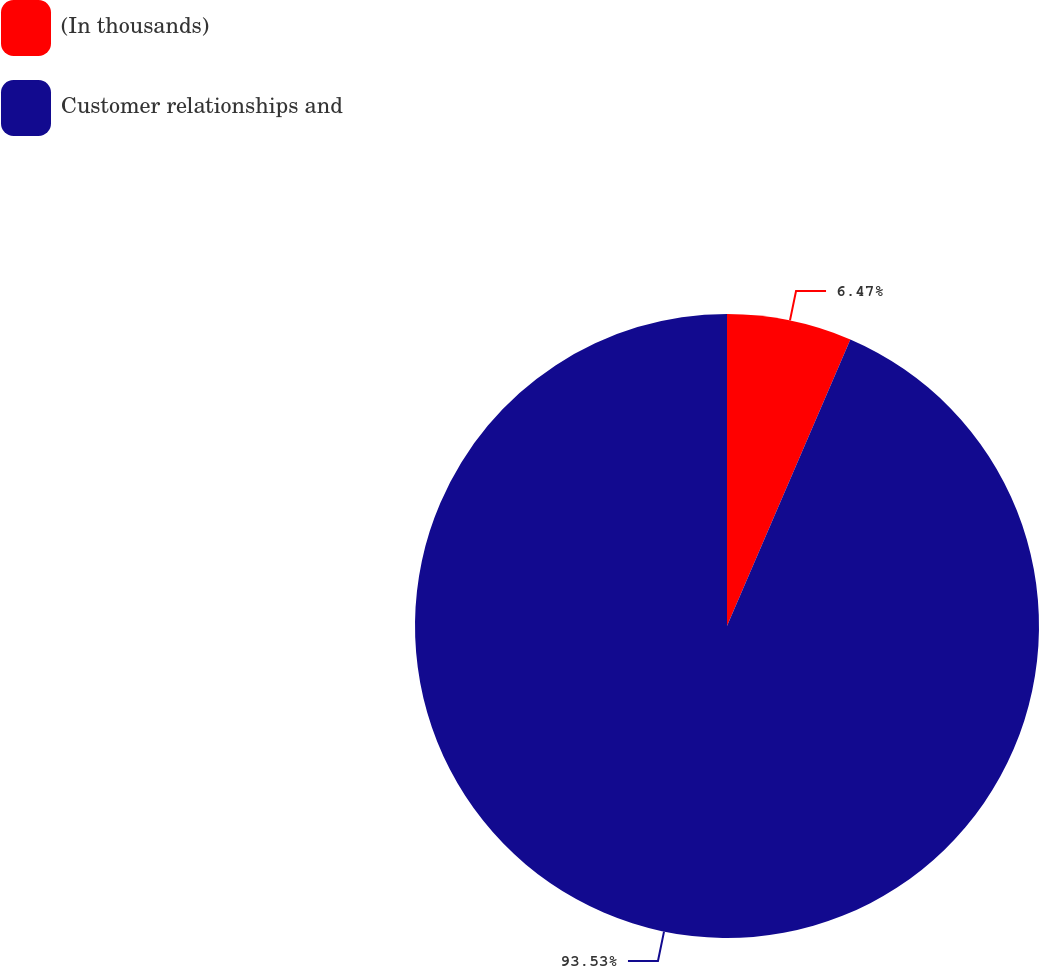Convert chart to OTSL. <chart><loc_0><loc_0><loc_500><loc_500><pie_chart><fcel>(In thousands)<fcel>Customer relationships and<nl><fcel>6.47%<fcel>93.53%<nl></chart> 